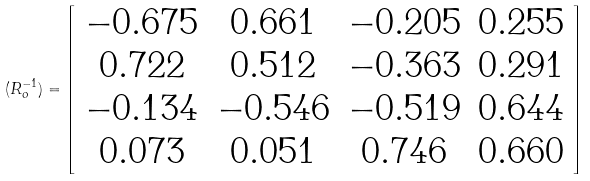<formula> <loc_0><loc_0><loc_500><loc_500>( R _ { o } ^ { - 1 } ) = \left [ \begin{array} { c c c c } - 0 . 6 7 5 & 0 . 6 6 1 & - 0 . 2 0 5 & 0 . 2 5 5 \\ 0 . 7 2 2 & 0 . 5 1 2 & - 0 . 3 6 3 & 0 . 2 9 1 \\ - 0 . 1 3 4 & - 0 . 5 4 6 & - 0 . 5 1 9 & 0 . 6 4 4 \\ 0 . 0 7 3 & 0 . 0 5 1 & 0 . 7 4 6 & 0 . 6 6 0 \\ \end{array} \right ]</formula> 